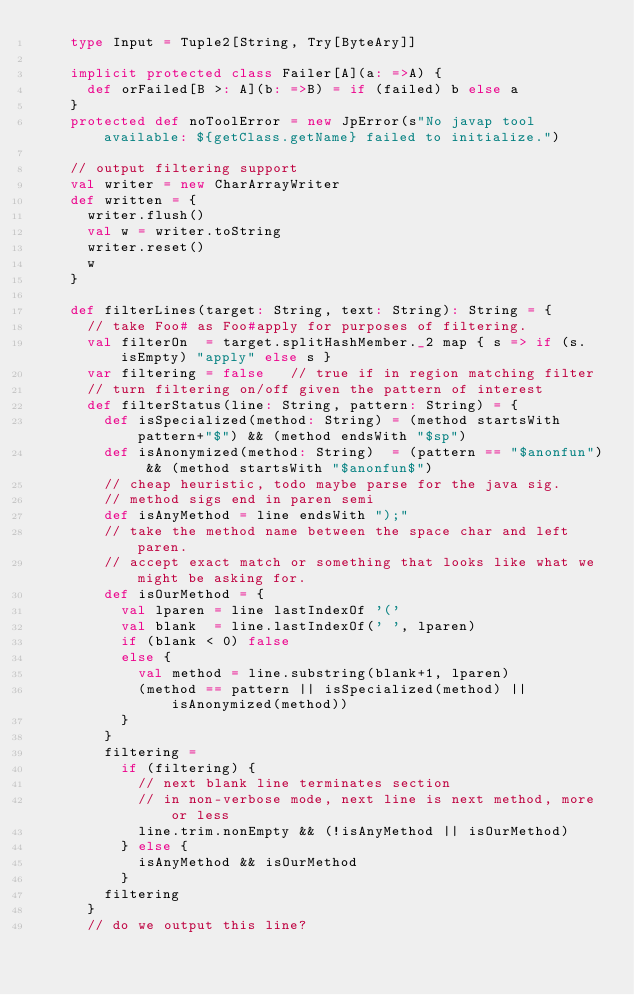<code> <loc_0><loc_0><loc_500><loc_500><_Scala_>    type Input = Tuple2[String, Try[ByteAry]]

    implicit protected class Failer[A](a: =>A) {
      def orFailed[B >: A](b: =>B) = if (failed) b else a
    }
    protected def noToolError = new JpError(s"No javap tool available: ${getClass.getName} failed to initialize.")

    // output filtering support
    val writer = new CharArrayWriter
    def written = {
      writer.flush()
      val w = writer.toString
      writer.reset()
      w
    }

    def filterLines(target: String, text: String): String = {
      // take Foo# as Foo#apply for purposes of filtering.
      val filterOn  = target.splitHashMember._2 map { s => if (s.isEmpty) "apply" else s }
      var filtering = false   // true if in region matching filter
      // turn filtering on/off given the pattern of interest
      def filterStatus(line: String, pattern: String) = {
        def isSpecialized(method: String) = (method startsWith pattern+"$") && (method endsWith "$sp")
        def isAnonymized(method: String)  = (pattern == "$anonfun") && (method startsWith "$anonfun$")
        // cheap heuristic, todo maybe parse for the java sig.
        // method sigs end in paren semi
        def isAnyMethod = line endsWith ");"
        // take the method name between the space char and left paren.
        // accept exact match or something that looks like what we might be asking for.
        def isOurMethod = {
          val lparen = line lastIndexOf '('
          val blank  = line.lastIndexOf(' ', lparen)
          if (blank < 0) false
          else {
            val method = line.substring(blank+1, lparen)
            (method == pattern || isSpecialized(method) || isAnonymized(method))
          }
        }
        filtering =
          if (filtering) {
            // next blank line terminates section
            // in non-verbose mode, next line is next method, more or less
            line.trim.nonEmpty && (!isAnyMethod || isOurMethod)
          } else {
            isAnyMethod && isOurMethod
          }
        filtering
      }
      // do we output this line?</code> 